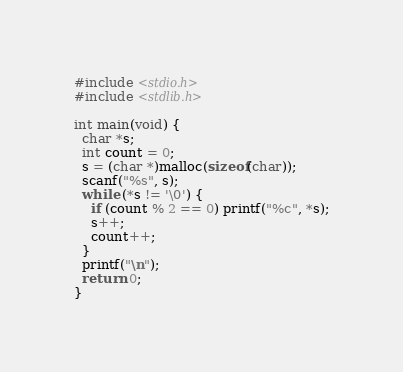Convert code to text. <code><loc_0><loc_0><loc_500><loc_500><_C_>#include <stdio.h>
#include <stdlib.h>

int main(void) {
  char *s;
  int count = 0;
  s = (char *)malloc(sizeof(char));
  scanf("%s", s);
  while (*s != '\0') {
    if (count % 2 == 0) printf("%c", *s);
    s++;
    count++;
  }
  printf("\n");
  return 0;
}</code> 